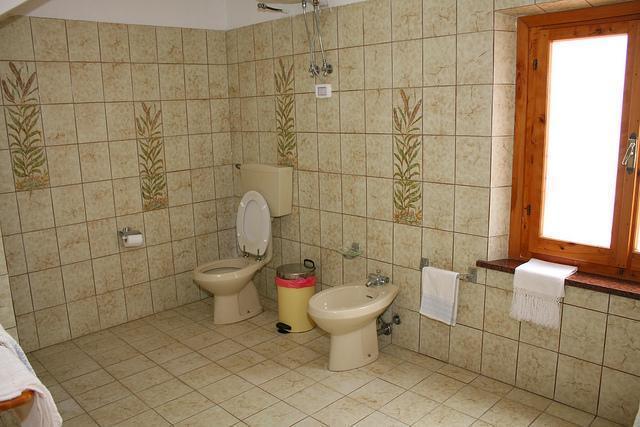How many towels are in the room?
Give a very brief answer. 3. How many towels are in the picture?
Give a very brief answer. 3. How many compartments does the suitcase have?
Give a very brief answer. 0. 